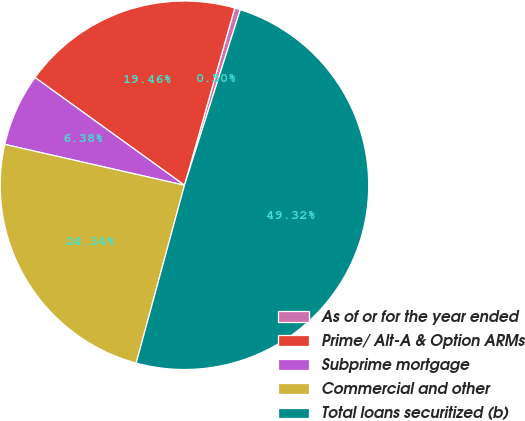<chart> <loc_0><loc_0><loc_500><loc_500><pie_chart><fcel>As of or for the year ended<fcel>Prime/ Alt-A & Option ARMs<fcel>Subprime mortgage<fcel>Commercial and other<fcel>Total loans securitized (b)<nl><fcel>0.5%<fcel>19.46%<fcel>6.38%<fcel>24.34%<fcel>49.32%<nl></chart> 